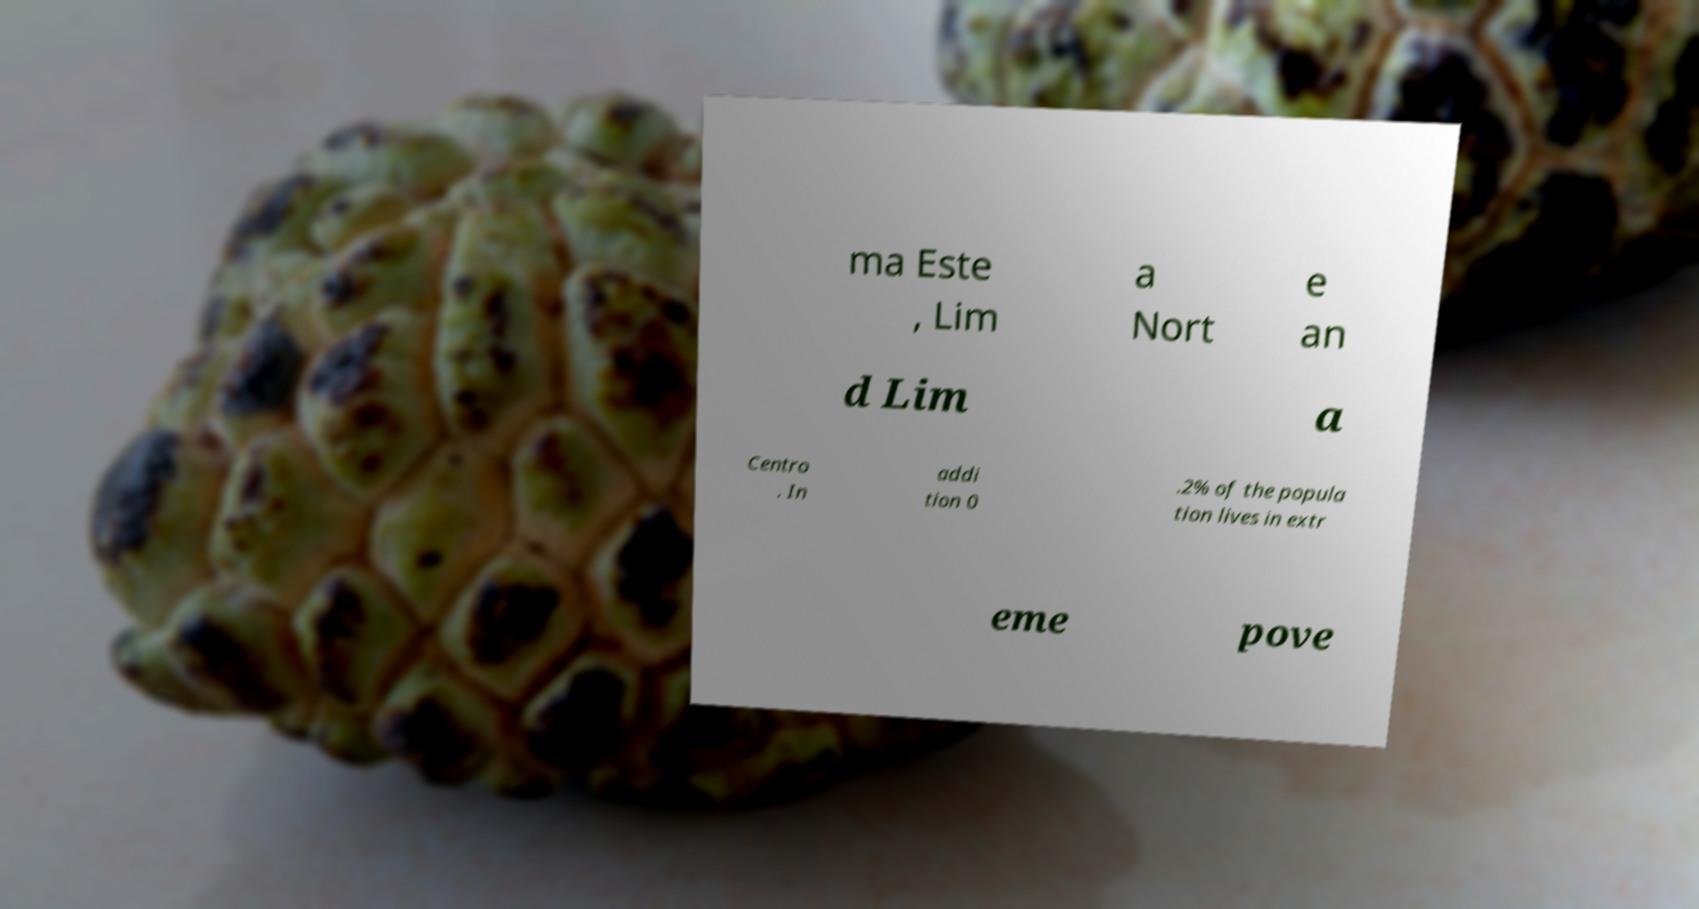Please read and relay the text visible in this image. What does it say? ma Este , Lim a Nort e an d Lim a Centro . In addi tion 0 .2% of the popula tion lives in extr eme pove 